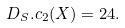Convert formula to latex. <formula><loc_0><loc_0><loc_500><loc_500>D _ { S } . c _ { 2 } ( X ) = 2 4 .</formula> 